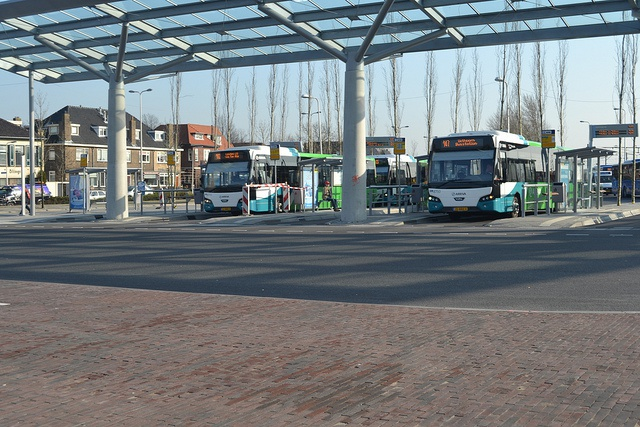Describe the objects in this image and their specific colors. I can see bus in lightblue, black, gray, darkgray, and blue tones, bus in lightblue, black, gray, and darkgray tones, bus in lightblue, black, darkgray, gray, and lightgray tones, bus in lightblue, black, navy, gray, and darkblue tones, and people in lightblue, gray, black, and darkblue tones in this image. 